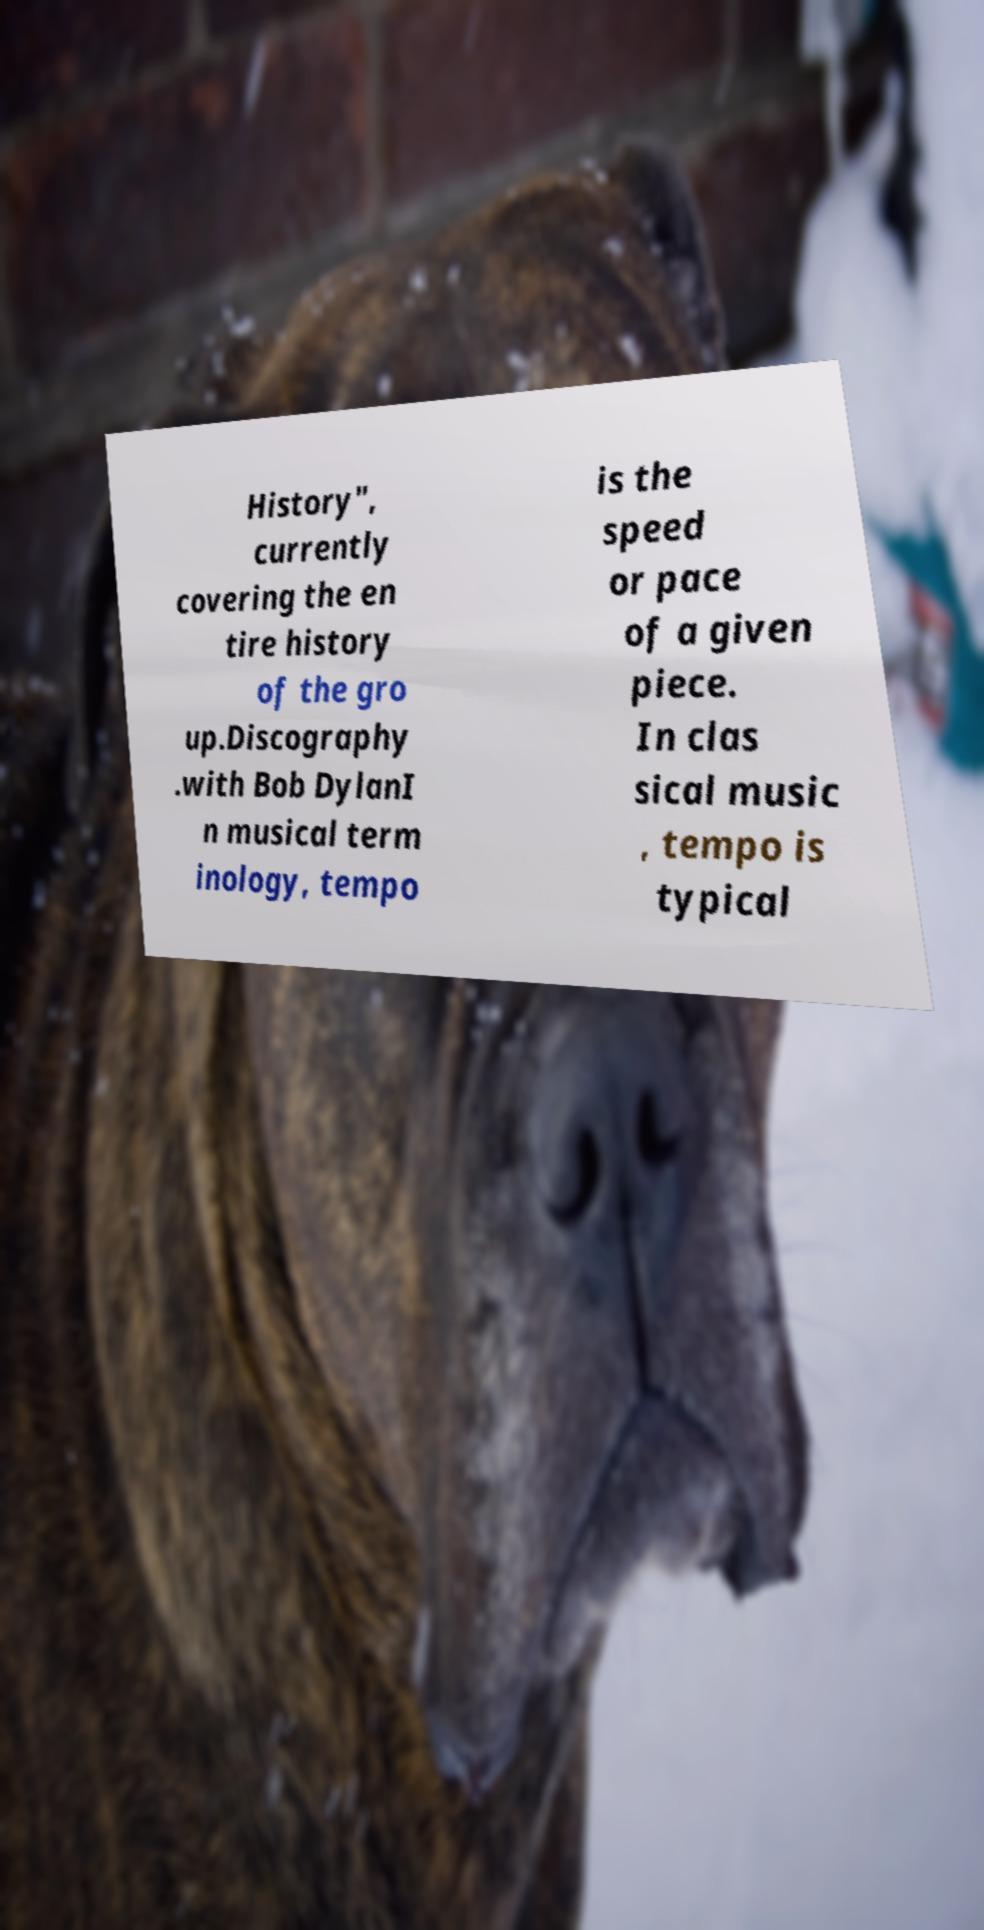What messages or text are displayed in this image? I need them in a readable, typed format. History", currently covering the en tire history of the gro up.Discography .with Bob DylanI n musical term inology, tempo is the speed or pace of a given piece. In clas sical music , tempo is typical 